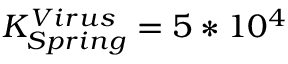Convert formula to latex. <formula><loc_0><loc_0><loc_500><loc_500>K _ { S p r i n g } ^ { V i r u s } = 5 * 1 0 ^ { 4 }</formula> 